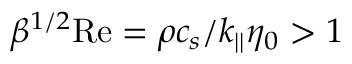Convert formula to latex. <formula><loc_0><loc_0><loc_500><loc_500>\beta ^ { 1 / 2 } R e = \rho c _ { s } / k _ { | | } \eta _ { 0 } > 1</formula> 